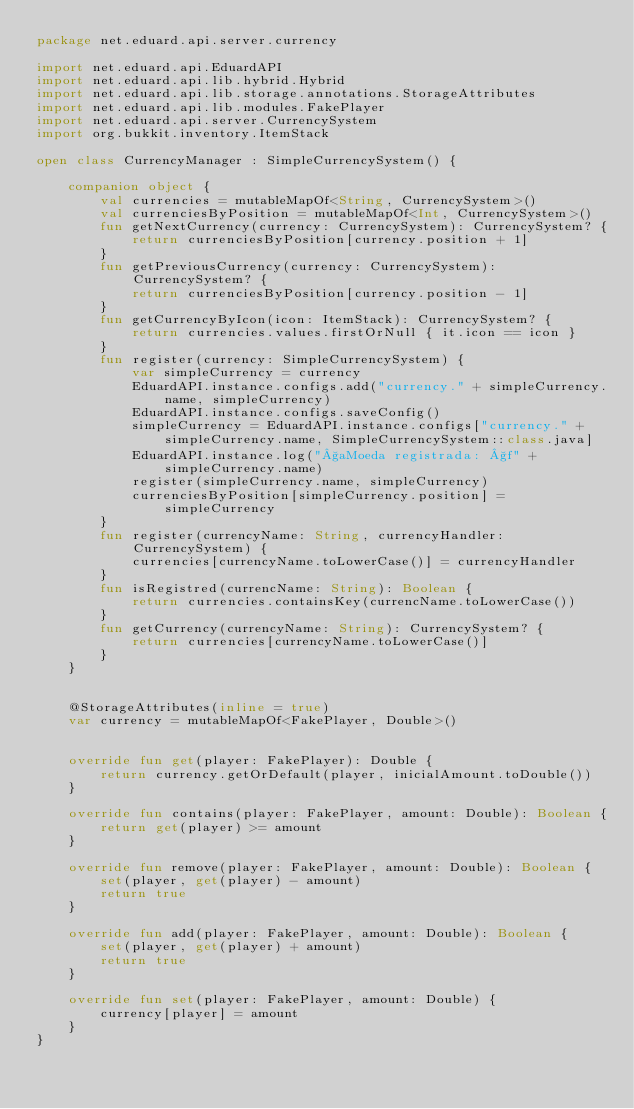<code> <loc_0><loc_0><loc_500><loc_500><_Kotlin_>package net.eduard.api.server.currency

import net.eduard.api.EduardAPI
import net.eduard.api.lib.hybrid.Hybrid
import net.eduard.api.lib.storage.annotations.StorageAttributes
import net.eduard.api.lib.modules.FakePlayer
import net.eduard.api.server.CurrencySystem
import org.bukkit.inventory.ItemStack

open class CurrencyManager : SimpleCurrencySystem() {

    companion object {
        val currencies = mutableMapOf<String, CurrencySystem>()
        val currenciesByPosition = mutableMapOf<Int, CurrencySystem>()
        fun getNextCurrency(currency: CurrencySystem): CurrencySystem? {
            return currenciesByPosition[currency.position + 1]
        }
        fun getPreviousCurrency(currency: CurrencySystem): CurrencySystem? {
            return currenciesByPosition[currency.position - 1]
        }
        fun getCurrencyByIcon(icon: ItemStack): CurrencySystem? {
            return currencies.values.firstOrNull { it.icon == icon }
        }
        fun register(currency: SimpleCurrencySystem) {
            var simpleCurrency = currency
            EduardAPI.instance.configs.add("currency." + simpleCurrency.name, simpleCurrency)
            EduardAPI.instance.configs.saveConfig()
            simpleCurrency = EduardAPI.instance.configs["currency." + simpleCurrency.name, SimpleCurrencySystem::class.java]
            EduardAPI.instance.log("§aMoeda registrada: §f" + simpleCurrency.name)
            register(simpleCurrency.name, simpleCurrency)
            currenciesByPosition[simpleCurrency.position] = simpleCurrency
        }
        fun register(currencyName: String, currencyHandler: CurrencySystem) {
            currencies[currencyName.toLowerCase()] = currencyHandler
        }
        fun isRegistred(currencName: String): Boolean {
            return currencies.containsKey(currencName.toLowerCase())
        }
        fun getCurrency(currencyName: String): CurrencySystem? {
            return currencies[currencyName.toLowerCase()]
        }
    }


    @StorageAttributes(inline = true)
    var currency = mutableMapOf<FakePlayer, Double>()


    override fun get(player: FakePlayer): Double {
        return currency.getOrDefault(player, inicialAmount.toDouble())
    }

    override fun contains(player: FakePlayer, amount: Double): Boolean {
        return get(player) >= amount
    }

    override fun remove(player: FakePlayer, amount: Double): Boolean {
        set(player, get(player) - amount)
        return true
    }

    override fun add(player: FakePlayer, amount: Double): Boolean {
        set(player, get(player) + amount)
        return true
    }

    override fun set(player: FakePlayer, amount: Double) {
        currency[player] = amount
    }
}</code> 